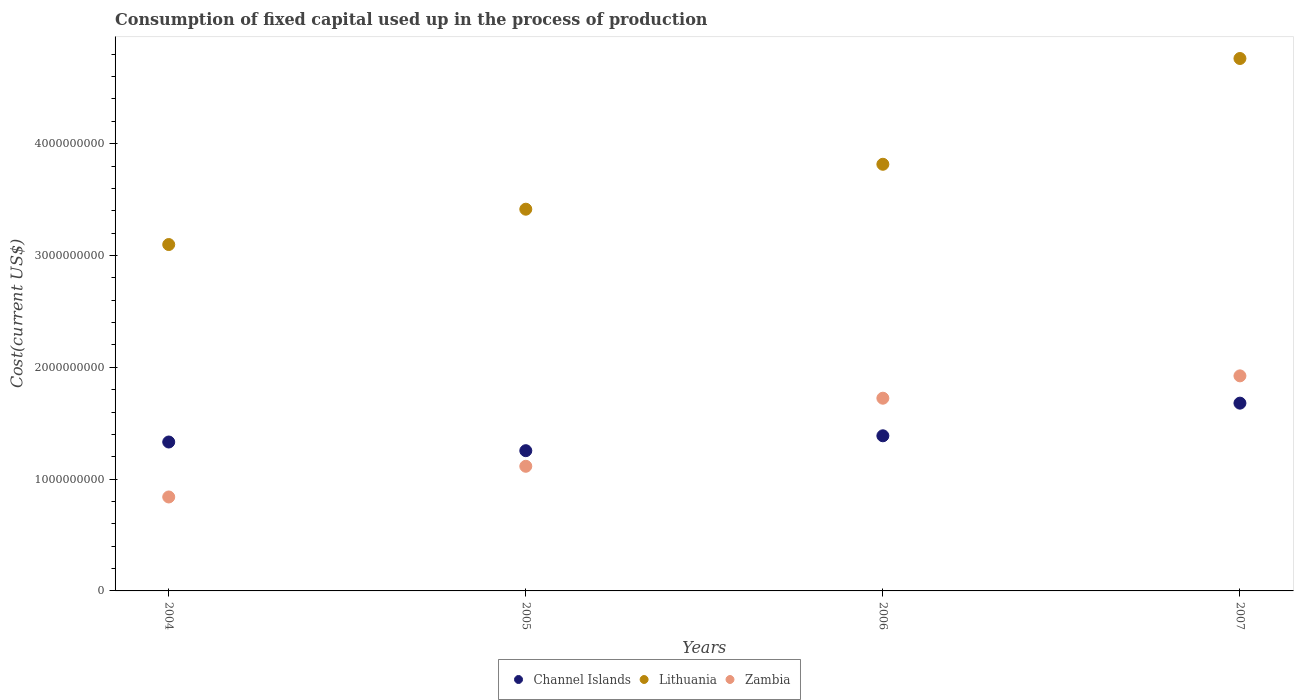What is the amount consumed in the process of production in Channel Islands in 2004?
Your answer should be compact. 1.33e+09. Across all years, what is the maximum amount consumed in the process of production in Channel Islands?
Give a very brief answer. 1.68e+09. Across all years, what is the minimum amount consumed in the process of production in Zambia?
Your response must be concise. 8.40e+08. In which year was the amount consumed in the process of production in Zambia minimum?
Your response must be concise. 2004. What is the total amount consumed in the process of production in Zambia in the graph?
Provide a succinct answer. 5.60e+09. What is the difference between the amount consumed in the process of production in Lithuania in 2004 and that in 2005?
Provide a succinct answer. -3.16e+08. What is the difference between the amount consumed in the process of production in Lithuania in 2004 and the amount consumed in the process of production in Channel Islands in 2005?
Offer a very short reply. 1.84e+09. What is the average amount consumed in the process of production in Channel Islands per year?
Make the answer very short. 1.41e+09. In the year 2005, what is the difference between the amount consumed in the process of production in Channel Islands and amount consumed in the process of production in Lithuania?
Provide a succinct answer. -2.16e+09. What is the ratio of the amount consumed in the process of production in Lithuania in 2004 to that in 2007?
Give a very brief answer. 0.65. Is the difference between the amount consumed in the process of production in Channel Islands in 2005 and 2007 greater than the difference between the amount consumed in the process of production in Lithuania in 2005 and 2007?
Give a very brief answer. Yes. What is the difference between the highest and the second highest amount consumed in the process of production in Channel Islands?
Offer a terse response. 2.92e+08. What is the difference between the highest and the lowest amount consumed in the process of production in Zambia?
Offer a terse response. 1.08e+09. In how many years, is the amount consumed in the process of production in Lithuania greater than the average amount consumed in the process of production in Lithuania taken over all years?
Offer a terse response. 2. Is the amount consumed in the process of production in Lithuania strictly less than the amount consumed in the process of production in Zambia over the years?
Ensure brevity in your answer.  No. What is the difference between two consecutive major ticks on the Y-axis?
Your answer should be compact. 1.00e+09. Does the graph contain any zero values?
Your answer should be compact. No. Does the graph contain grids?
Offer a terse response. No. What is the title of the graph?
Your answer should be very brief. Consumption of fixed capital used up in the process of production. What is the label or title of the Y-axis?
Provide a succinct answer. Cost(current US$). What is the Cost(current US$) of Channel Islands in 2004?
Offer a very short reply. 1.33e+09. What is the Cost(current US$) in Lithuania in 2004?
Ensure brevity in your answer.  3.10e+09. What is the Cost(current US$) of Zambia in 2004?
Make the answer very short. 8.40e+08. What is the Cost(current US$) in Channel Islands in 2005?
Make the answer very short. 1.25e+09. What is the Cost(current US$) of Lithuania in 2005?
Your answer should be compact. 3.41e+09. What is the Cost(current US$) of Zambia in 2005?
Keep it short and to the point. 1.11e+09. What is the Cost(current US$) of Channel Islands in 2006?
Your answer should be compact. 1.39e+09. What is the Cost(current US$) in Lithuania in 2006?
Give a very brief answer. 3.82e+09. What is the Cost(current US$) in Zambia in 2006?
Ensure brevity in your answer.  1.72e+09. What is the Cost(current US$) of Channel Islands in 2007?
Your answer should be compact. 1.68e+09. What is the Cost(current US$) in Lithuania in 2007?
Ensure brevity in your answer.  4.76e+09. What is the Cost(current US$) in Zambia in 2007?
Give a very brief answer. 1.92e+09. Across all years, what is the maximum Cost(current US$) in Channel Islands?
Your answer should be very brief. 1.68e+09. Across all years, what is the maximum Cost(current US$) of Lithuania?
Keep it short and to the point. 4.76e+09. Across all years, what is the maximum Cost(current US$) in Zambia?
Your answer should be very brief. 1.92e+09. Across all years, what is the minimum Cost(current US$) in Channel Islands?
Offer a very short reply. 1.25e+09. Across all years, what is the minimum Cost(current US$) of Lithuania?
Ensure brevity in your answer.  3.10e+09. Across all years, what is the minimum Cost(current US$) of Zambia?
Give a very brief answer. 8.40e+08. What is the total Cost(current US$) in Channel Islands in the graph?
Give a very brief answer. 5.65e+09. What is the total Cost(current US$) in Lithuania in the graph?
Your answer should be compact. 1.51e+1. What is the total Cost(current US$) in Zambia in the graph?
Make the answer very short. 5.60e+09. What is the difference between the Cost(current US$) of Channel Islands in 2004 and that in 2005?
Keep it short and to the point. 7.76e+07. What is the difference between the Cost(current US$) of Lithuania in 2004 and that in 2005?
Your answer should be compact. -3.16e+08. What is the difference between the Cost(current US$) in Zambia in 2004 and that in 2005?
Your answer should be compact. -2.74e+08. What is the difference between the Cost(current US$) of Channel Islands in 2004 and that in 2006?
Provide a succinct answer. -5.56e+07. What is the difference between the Cost(current US$) of Lithuania in 2004 and that in 2006?
Your answer should be very brief. -7.18e+08. What is the difference between the Cost(current US$) of Zambia in 2004 and that in 2006?
Offer a very short reply. -8.83e+08. What is the difference between the Cost(current US$) of Channel Islands in 2004 and that in 2007?
Your answer should be compact. -3.48e+08. What is the difference between the Cost(current US$) in Lithuania in 2004 and that in 2007?
Offer a terse response. -1.66e+09. What is the difference between the Cost(current US$) in Zambia in 2004 and that in 2007?
Ensure brevity in your answer.  -1.08e+09. What is the difference between the Cost(current US$) of Channel Islands in 2005 and that in 2006?
Make the answer very short. -1.33e+08. What is the difference between the Cost(current US$) in Lithuania in 2005 and that in 2006?
Your answer should be compact. -4.02e+08. What is the difference between the Cost(current US$) of Zambia in 2005 and that in 2006?
Give a very brief answer. -6.09e+08. What is the difference between the Cost(current US$) in Channel Islands in 2005 and that in 2007?
Ensure brevity in your answer.  -4.25e+08. What is the difference between the Cost(current US$) of Lithuania in 2005 and that in 2007?
Keep it short and to the point. -1.35e+09. What is the difference between the Cost(current US$) in Zambia in 2005 and that in 2007?
Provide a short and direct response. -8.09e+08. What is the difference between the Cost(current US$) in Channel Islands in 2006 and that in 2007?
Provide a short and direct response. -2.92e+08. What is the difference between the Cost(current US$) of Lithuania in 2006 and that in 2007?
Keep it short and to the point. -9.46e+08. What is the difference between the Cost(current US$) of Zambia in 2006 and that in 2007?
Make the answer very short. -2.00e+08. What is the difference between the Cost(current US$) in Channel Islands in 2004 and the Cost(current US$) in Lithuania in 2005?
Provide a succinct answer. -2.08e+09. What is the difference between the Cost(current US$) in Channel Islands in 2004 and the Cost(current US$) in Zambia in 2005?
Make the answer very short. 2.17e+08. What is the difference between the Cost(current US$) in Lithuania in 2004 and the Cost(current US$) in Zambia in 2005?
Make the answer very short. 1.98e+09. What is the difference between the Cost(current US$) in Channel Islands in 2004 and the Cost(current US$) in Lithuania in 2006?
Your answer should be compact. -2.48e+09. What is the difference between the Cost(current US$) in Channel Islands in 2004 and the Cost(current US$) in Zambia in 2006?
Your answer should be very brief. -3.92e+08. What is the difference between the Cost(current US$) in Lithuania in 2004 and the Cost(current US$) in Zambia in 2006?
Your answer should be compact. 1.37e+09. What is the difference between the Cost(current US$) in Channel Islands in 2004 and the Cost(current US$) in Lithuania in 2007?
Your response must be concise. -3.43e+09. What is the difference between the Cost(current US$) of Channel Islands in 2004 and the Cost(current US$) of Zambia in 2007?
Provide a succinct answer. -5.92e+08. What is the difference between the Cost(current US$) in Lithuania in 2004 and the Cost(current US$) in Zambia in 2007?
Make the answer very short. 1.17e+09. What is the difference between the Cost(current US$) of Channel Islands in 2005 and the Cost(current US$) of Lithuania in 2006?
Make the answer very short. -2.56e+09. What is the difference between the Cost(current US$) in Channel Islands in 2005 and the Cost(current US$) in Zambia in 2006?
Provide a short and direct response. -4.69e+08. What is the difference between the Cost(current US$) in Lithuania in 2005 and the Cost(current US$) in Zambia in 2006?
Provide a succinct answer. 1.69e+09. What is the difference between the Cost(current US$) in Channel Islands in 2005 and the Cost(current US$) in Lithuania in 2007?
Keep it short and to the point. -3.51e+09. What is the difference between the Cost(current US$) in Channel Islands in 2005 and the Cost(current US$) in Zambia in 2007?
Offer a very short reply. -6.69e+08. What is the difference between the Cost(current US$) in Lithuania in 2005 and the Cost(current US$) in Zambia in 2007?
Give a very brief answer. 1.49e+09. What is the difference between the Cost(current US$) of Channel Islands in 2006 and the Cost(current US$) of Lithuania in 2007?
Your answer should be very brief. -3.37e+09. What is the difference between the Cost(current US$) in Channel Islands in 2006 and the Cost(current US$) in Zambia in 2007?
Your answer should be very brief. -5.36e+08. What is the difference between the Cost(current US$) in Lithuania in 2006 and the Cost(current US$) in Zambia in 2007?
Offer a very short reply. 1.89e+09. What is the average Cost(current US$) of Channel Islands per year?
Give a very brief answer. 1.41e+09. What is the average Cost(current US$) of Lithuania per year?
Ensure brevity in your answer.  3.77e+09. What is the average Cost(current US$) in Zambia per year?
Make the answer very short. 1.40e+09. In the year 2004, what is the difference between the Cost(current US$) in Channel Islands and Cost(current US$) in Lithuania?
Make the answer very short. -1.77e+09. In the year 2004, what is the difference between the Cost(current US$) of Channel Islands and Cost(current US$) of Zambia?
Provide a succinct answer. 4.92e+08. In the year 2004, what is the difference between the Cost(current US$) of Lithuania and Cost(current US$) of Zambia?
Provide a succinct answer. 2.26e+09. In the year 2005, what is the difference between the Cost(current US$) in Channel Islands and Cost(current US$) in Lithuania?
Provide a short and direct response. -2.16e+09. In the year 2005, what is the difference between the Cost(current US$) in Channel Islands and Cost(current US$) in Zambia?
Give a very brief answer. 1.39e+08. In the year 2005, what is the difference between the Cost(current US$) in Lithuania and Cost(current US$) in Zambia?
Offer a terse response. 2.30e+09. In the year 2006, what is the difference between the Cost(current US$) in Channel Islands and Cost(current US$) in Lithuania?
Provide a succinct answer. -2.43e+09. In the year 2006, what is the difference between the Cost(current US$) in Channel Islands and Cost(current US$) in Zambia?
Your answer should be very brief. -3.36e+08. In the year 2006, what is the difference between the Cost(current US$) in Lithuania and Cost(current US$) in Zambia?
Your answer should be compact. 2.09e+09. In the year 2007, what is the difference between the Cost(current US$) in Channel Islands and Cost(current US$) in Lithuania?
Your answer should be very brief. -3.08e+09. In the year 2007, what is the difference between the Cost(current US$) of Channel Islands and Cost(current US$) of Zambia?
Offer a terse response. -2.44e+08. In the year 2007, what is the difference between the Cost(current US$) in Lithuania and Cost(current US$) in Zambia?
Your response must be concise. 2.84e+09. What is the ratio of the Cost(current US$) in Channel Islands in 2004 to that in 2005?
Offer a terse response. 1.06. What is the ratio of the Cost(current US$) in Lithuania in 2004 to that in 2005?
Provide a succinct answer. 0.91. What is the ratio of the Cost(current US$) in Zambia in 2004 to that in 2005?
Offer a terse response. 0.75. What is the ratio of the Cost(current US$) of Channel Islands in 2004 to that in 2006?
Provide a short and direct response. 0.96. What is the ratio of the Cost(current US$) in Lithuania in 2004 to that in 2006?
Provide a succinct answer. 0.81. What is the ratio of the Cost(current US$) of Zambia in 2004 to that in 2006?
Keep it short and to the point. 0.49. What is the ratio of the Cost(current US$) in Channel Islands in 2004 to that in 2007?
Provide a short and direct response. 0.79. What is the ratio of the Cost(current US$) of Lithuania in 2004 to that in 2007?
Offer a very short reply. 0.65. What is the ratio of the Cost(current US$) of Zambia in 2004 to that in 2007?
Ensure brevity in your answer.  0.44. What is the ratio of the Cost(current US$) of Channel Islands in 2005 to that in 2006?
Offer a very short reply. 0.9. What is the ratio of the Cost(current US$) of Lithuania in 2005 to that in 2006?
Ensure brevity in your answer.  0.89. What is the ratio of the Cost(current US$) of Zambia in 2005 to that in 2006?
Your answer should be compact. 0.65. What is the ratio of the Cost(current US$) of Channel Islands in 2005 to that in 2007?
Provide a short and direct response. 0.75. What is the ratio of the Cost(current US$) in Lithuania in 2005 to that in 2007?
Provide a succinct answer. 0.72. What is the ratio of the Cost(current US$) in Zambia in 2005 to that in 2007?
Make the answer very short. 0.58. What is the ratio of the Cost(current US$) in Channel Islands in 2006 to that in 2007?
Offer a terse response. 0.83. What is the ratio of the Cost(current US$) of Lithuania in 2006 to that in 2007?
Your response must be concise. 0.8. What is the ratio of the Cost(current US$) in Zambia in 2006 to that in 2007?
Offer a very short reply. 0.9. What is the difference between the highest and the second highest Cost(current US$) in Channel Islands?
Offer a very short reply. 2.92e+08. What is the difference between the highest and the second highest Cost(current US$) of Lithuania?
Make the answer very short. 9.46e+08. What is the difference between the highest and the second highest Cost(current US$) of Zambia?
Your answer should be compact. 2.00e+08. What is the difference between the highest and the lowest Cost(current US$) of Channel Islands?
Make the answer very short. 4.25e+08. What is the difference between the highest and the lowest Cost(current US$) of Lithuania?
Your answer should be compact. 1.66e+09. What is the difference between the highest and the lowest Cost(current US$) of Zambia?
Your answer should be compact. 1.08e+09. 